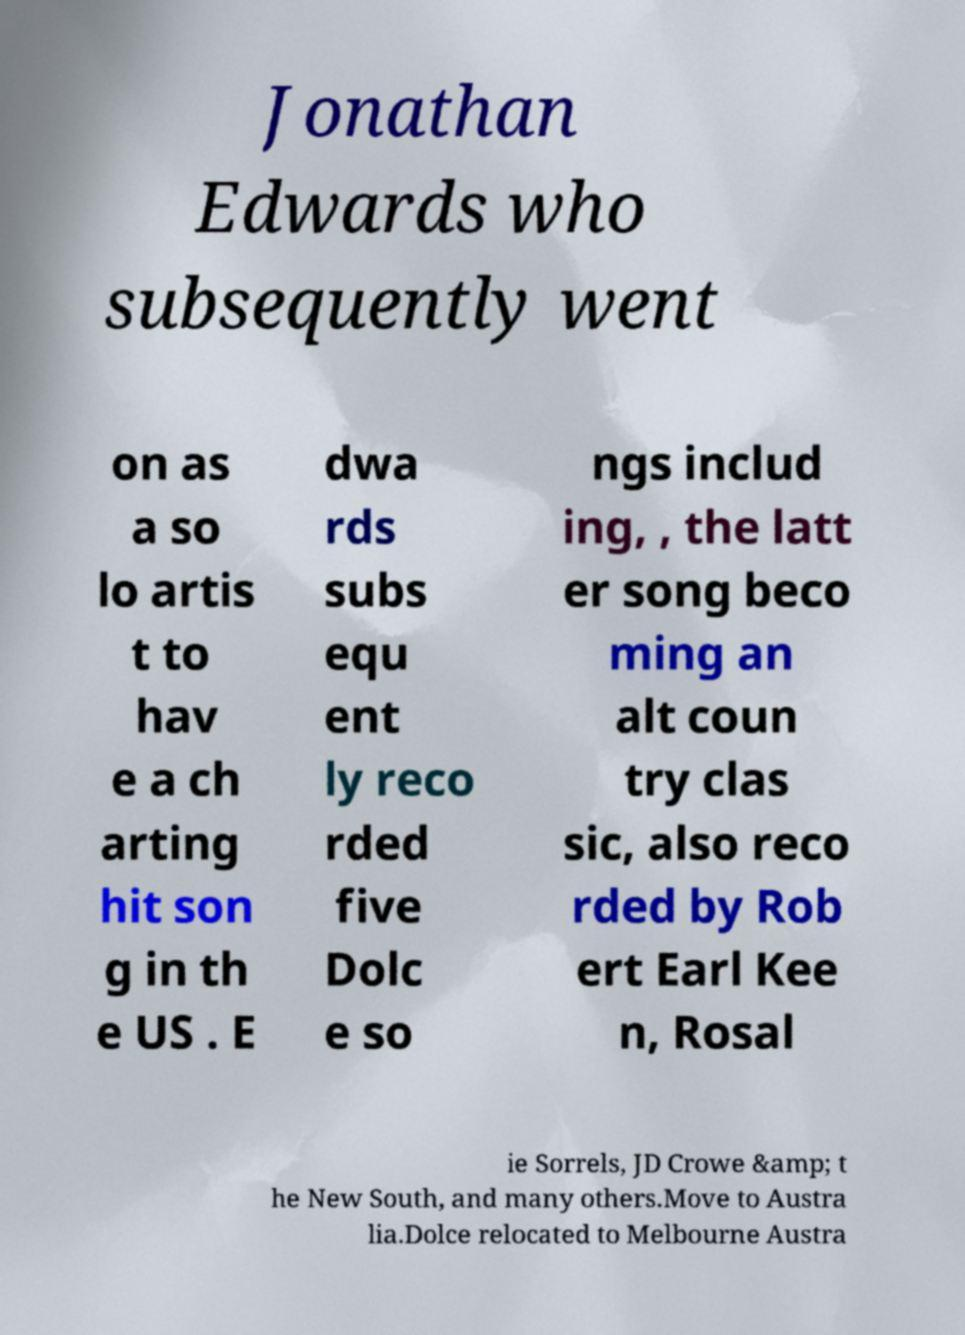I need the written content from this picture converted into text. Can you do that? Jonathan Edwards who subsequently went on as a so lo artis t to hav e a ch arting hit son g in th e US . E dwa rds subs equ ent ly reco rded five Dolc e so ngs includ ing, , the latt er song beco ming an alt coun try clas sic, also reco rded by Rob ert Earl Kee n, Rosal ie Sorrels, JD Crowe &amp; t he New South, and many others.Move to Austra lia.Dolce relocated to Melbourne Austra 